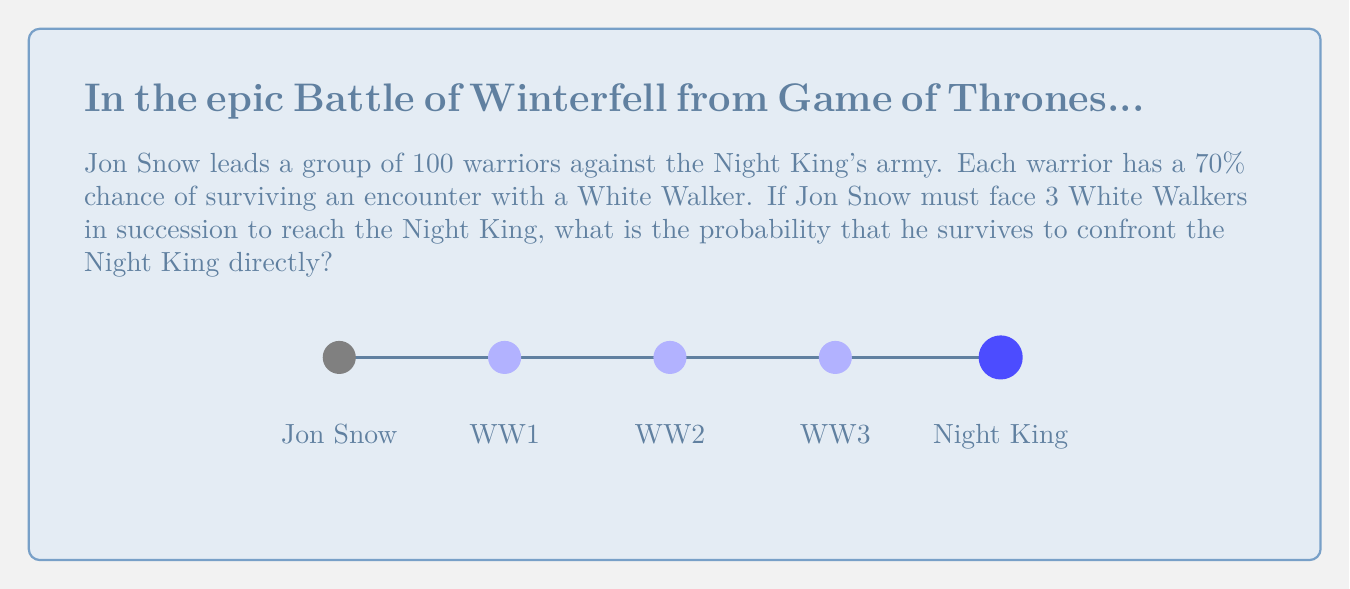Help me with this question. Let's approach this step-by-step:

1) Jon Snow must survive three consecutive encounters with White Walkers.

2) The probability of surviving each encounter is 70% or 0.7.

3) To survive all three encounters, Jon must survive the first AND the second AND the third. In probability, we multiply the individual probabilities when we need all events to occur.

4) Therefore, the probability of Jon surviving all three encounters is:

   $$P(\text{surviving all}) = 0.7 \times 0.7 \times 0.7 = 0.7^3$$

5) Let's calculate this:

   $$0.7^3 = 0.343$$

6) We can express this as a percentage:

   $$0.343 \times 100\% = 34.3\%$$

Thus, Jon Snow has a 34.3% chance of surviving to confront the Night King directly.
Answer: $34.3\%$ 